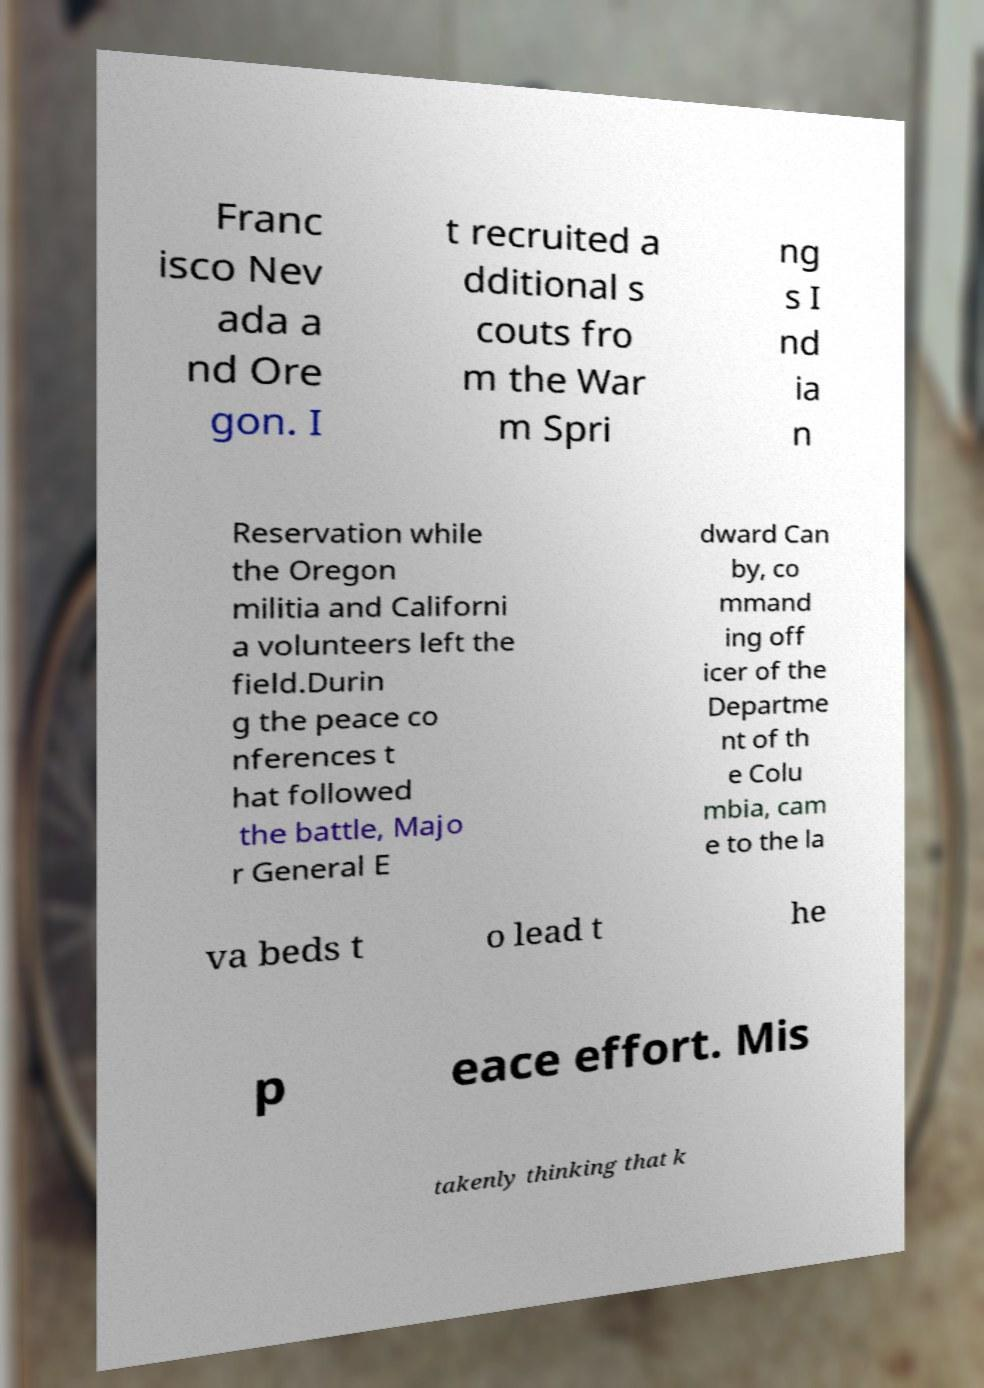Can you read and provide the text displayed in the image?This photo seems to have some interesting text. Can you extract and type it out for me? Franc isco Nev ada a nd Ore gon. I t recruited a dditional s couts fro m the War m Spri ng s I nd ia n Reservation while the Oregon militia and Californi a volunteers left the field.Durin g the peace co nferences t hat followed the battle, Majo r General E dward Can by, co mmand ing off icer of the Departme nt of th e Colu mbia, cam e to the la va beds t o lead t he p eace effort. Mis takenly thinking that k 